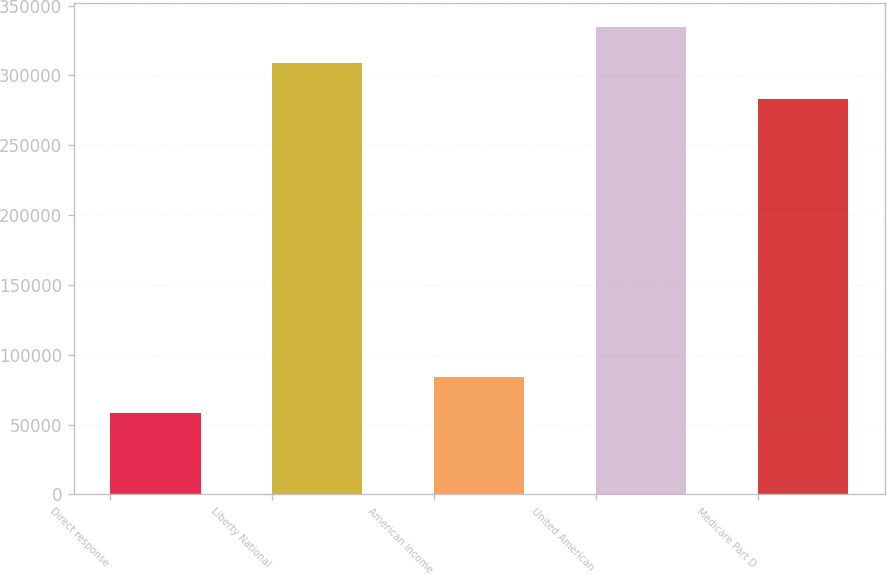Convert chart. <chart><loc_0><loc_0><loc_500><loc_500><bar_chart><fcel>Direct response<fcel>Liberty National<fcel>American Income<fcel>United American<fcel>Medicare Part D<nl><fcel>58512<fcel>308906<fcel>84430.7<fcel>334824<fcel>282987<nl></chart> 